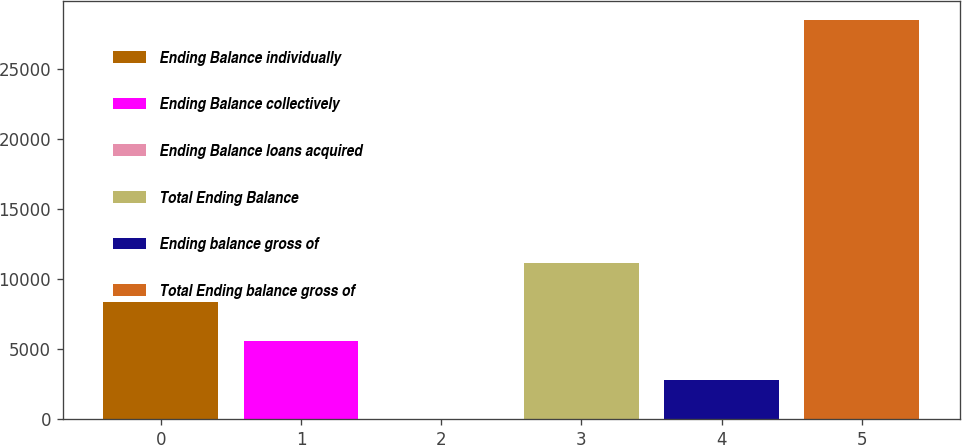Convert chart to OTSL. <chart><loc_0><loc_0><loc_500><loc_500><bar_chart><fcel>Ending Balance individually<fcel>Ending Balance collectively<fcel>Ending Balance loans acquired<fcel>Total Ending Balance<fcel>Ending balance gross of<fcel>Total Ending balance gross of<nl><fcel>8380.31<fcel>5587.36<fcel>1.46<fcel>11173.3<fcel>2794.41<fcel>28445<nl></chart> 